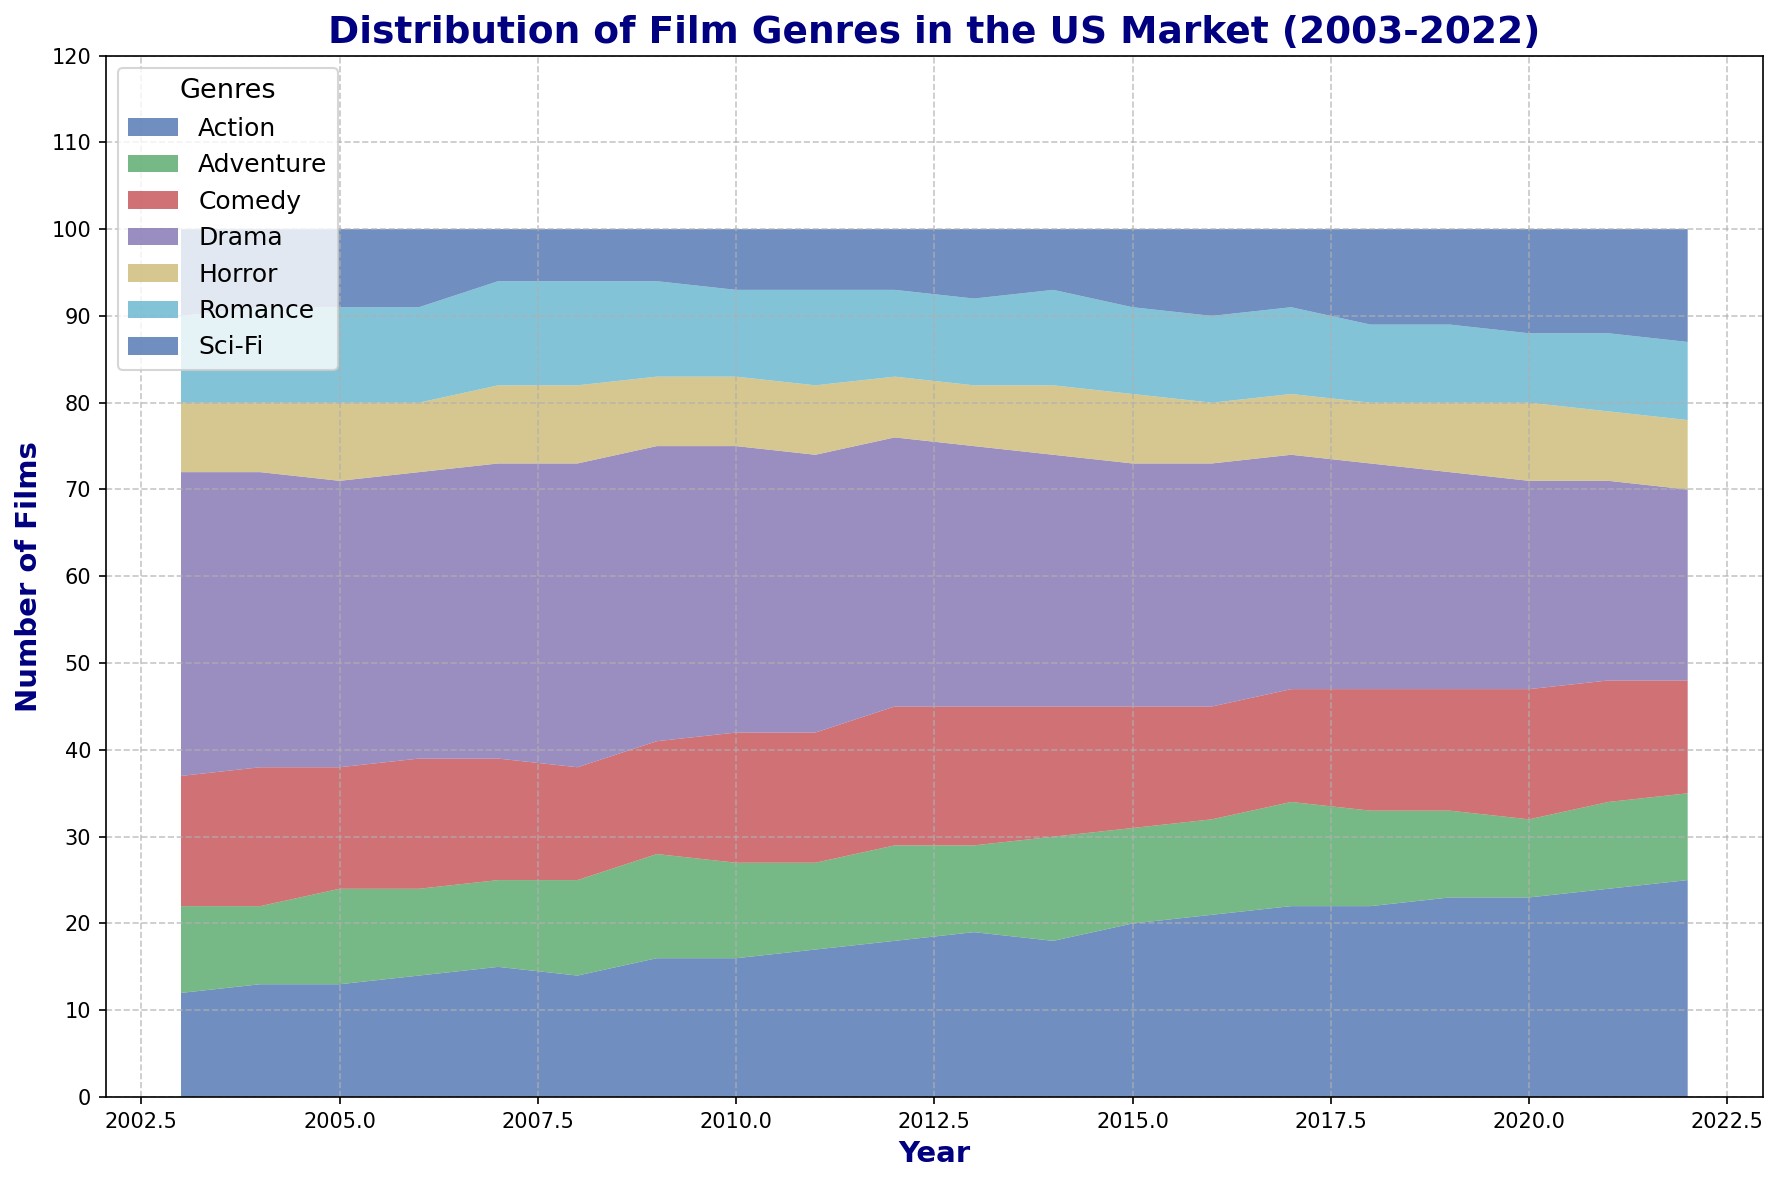How has the number of Action films changed from 2003 to 2022? To find the change, subtract the number of Action films in 2003 from the number in 2022. The number of Action films in 2003 is 12, and in 2022 it is 25. So, 25 - 12 = 13
Answer: 13 Which genre had the highest number of films in 2010? Check the values for each genre in the year 2010. The numbers are Action: 16, Adventure: 11, Comedy: 15, Drama: 33, Horror: 8, Romance: 10, Sci-Fi: 7. Drama has the highest number with 33 films
Answer: Drama How did the number of Sci-Fi films in 2018 compare to 2022? Look at the number of Sci-Fi films in 2018 and 2022. In 2018, there are 11 Sci-Fi films and in 2022, there are 13 Sci-Fi films. Compare these two values to see that 2022 has 2 more Sci-Fi films than 2018
Answer: 2 more Is the overall trend in the number of Comedy films increasing or decreasing over the 20 years? Observe the general trend from 2003 to 2022. In 2003, there are 15 Comedy films and by 2022, there are 13 Comedy films. The general trend is a slight decrease
Answer: Decreasing During which year was the number of Romance films the highest? Identify the peak number of Romance films over the years. In 2003, there are 10, and the highest value within this range is 12 in 2007 and 2008
Answer: 2007 and 2008 What were the total number of Horror films released in 2008 and 2018 combined? Add the number of Horror films in 2008 to the number in 2018. In 2008, there are 9 Horror films and in 2018 there are 7. So, 9 + 7 = 16
Answer: 16 Which genre remains the most consistent in the number of films released yearly? Compare the yearly numbers for each genre. Genres with more stable and less varying numbers are consistent. For example, Romance has values close to 10 almost every year.
Answer: Romance Has the number of Drama films been increasing or decreasing more sharply compared to Horror films? Look at the slope of the lines for Drama and Horror films. Drama starts at 35 in 2003 and decreases to 22 in 2022, and Horror fluctuates but starts at 8 and ends at 8. Drama decreases more sharply.
Answer: Decreasing more sharply What is the difference in the number of Action and Comedy films in 2015? Subtract the number of Comedy films from Action films in 2015. Action has 20 films and Comedy has 14. So, 20 - 14 = 6
Answer: 6 Which year had an equal number of Adventure and Sci-Fi films? Identify the year where the number of Adventure films is equal to the number of Sci-Fi films. In 2022, both Adventure and Sci-Fi have 10 films.
Answer: 2022 